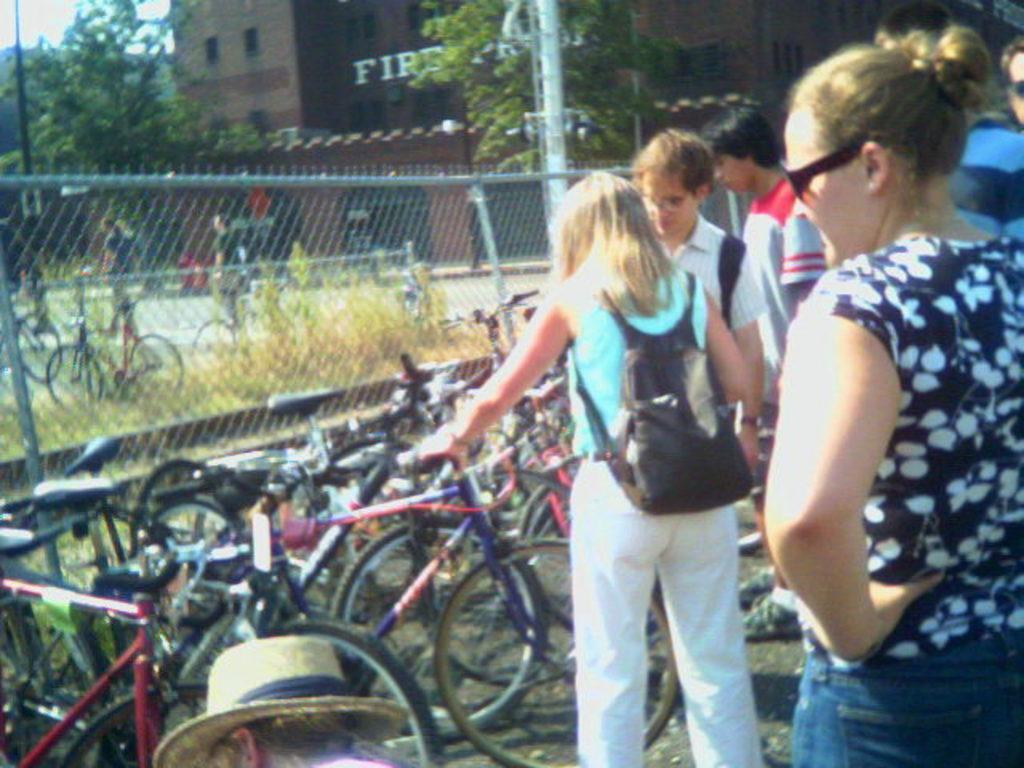How many people are in the group visible in the image? There is a group of people in the image, but the exact number cannot be determined from the provided facts. What are the people near the bicycles doing? The provided facts do not indicate what the people are doing near the bicycles. What can be seen in the background of the image? In the background of the image, there is a fence, a building, plants, and trees. Can you describe the setting of the image? The image appears to be set outdoors, with a group of people, bicycles, and various background elements visible. Is there a stream running through the image? There is no mention of a stream in the provided facts, so it cannot be determined if one is present in the image. 